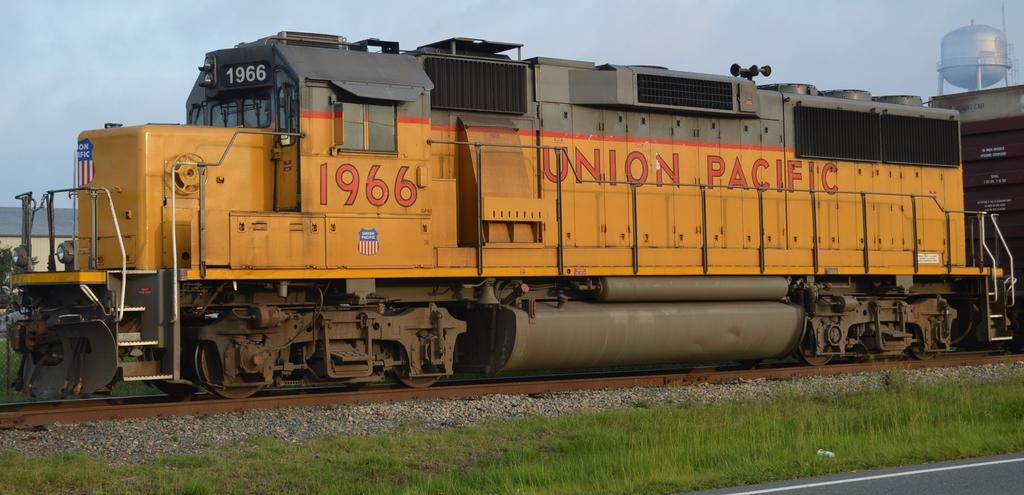What is the main subject of the image? The main subject of the image is a train. What can be seen on the train? There is text written on the train. What type of natural environment is visible in the image? There is grass in the image. What type of man-made environment is visible in the image? There is a road in the image. What type of barrier is present in the image? There is fencing in the image. What type of structure is present in the image? There is a shed in the image. What is visible at the top of the image? The sky is visible at the top of the image. What object is located in the top right corner of the image? There is an object in the top right corner of the image. What part of the train is being used to join the two cars together? There is no indication in the image of how the train cars are connected, and therefore we cannot determine which part is being used to join them. What type of pail can be seen in the image? There is no pail present in the image. 